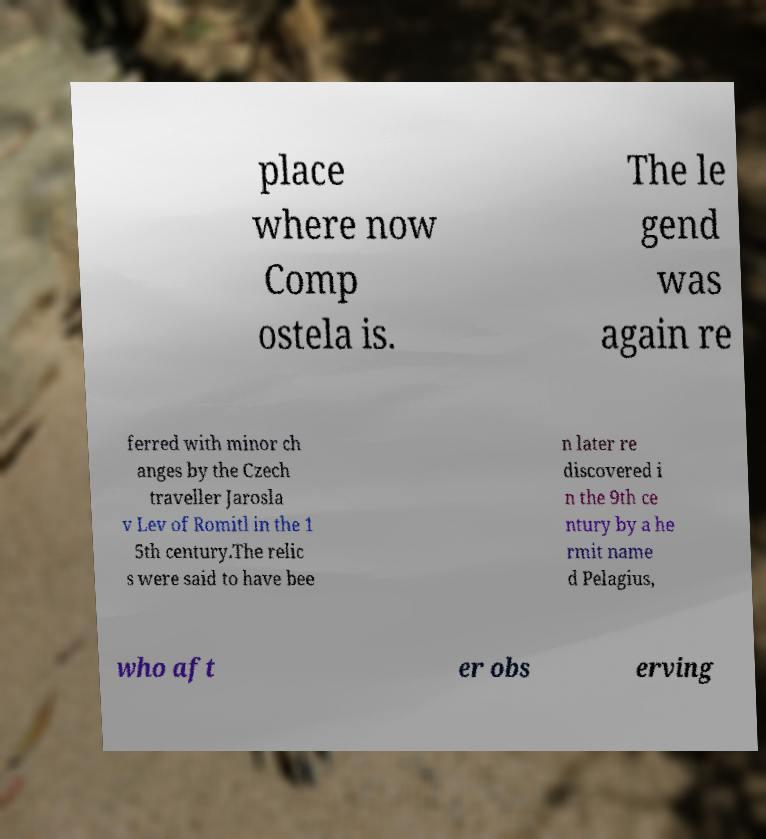There's text embedded in this image that I need extracted. Can you transcribe it verbatim? place where now Comp ostela is. The le gend was again re ferred with minor ch anges by the Czech traveller Jarosla v Lev of Romitl in the 1 5th century.The relic s were said to have bee n later re discovered i n the 9th ce ntury by a he rmit name d Pelagius, who aft er obs erving 